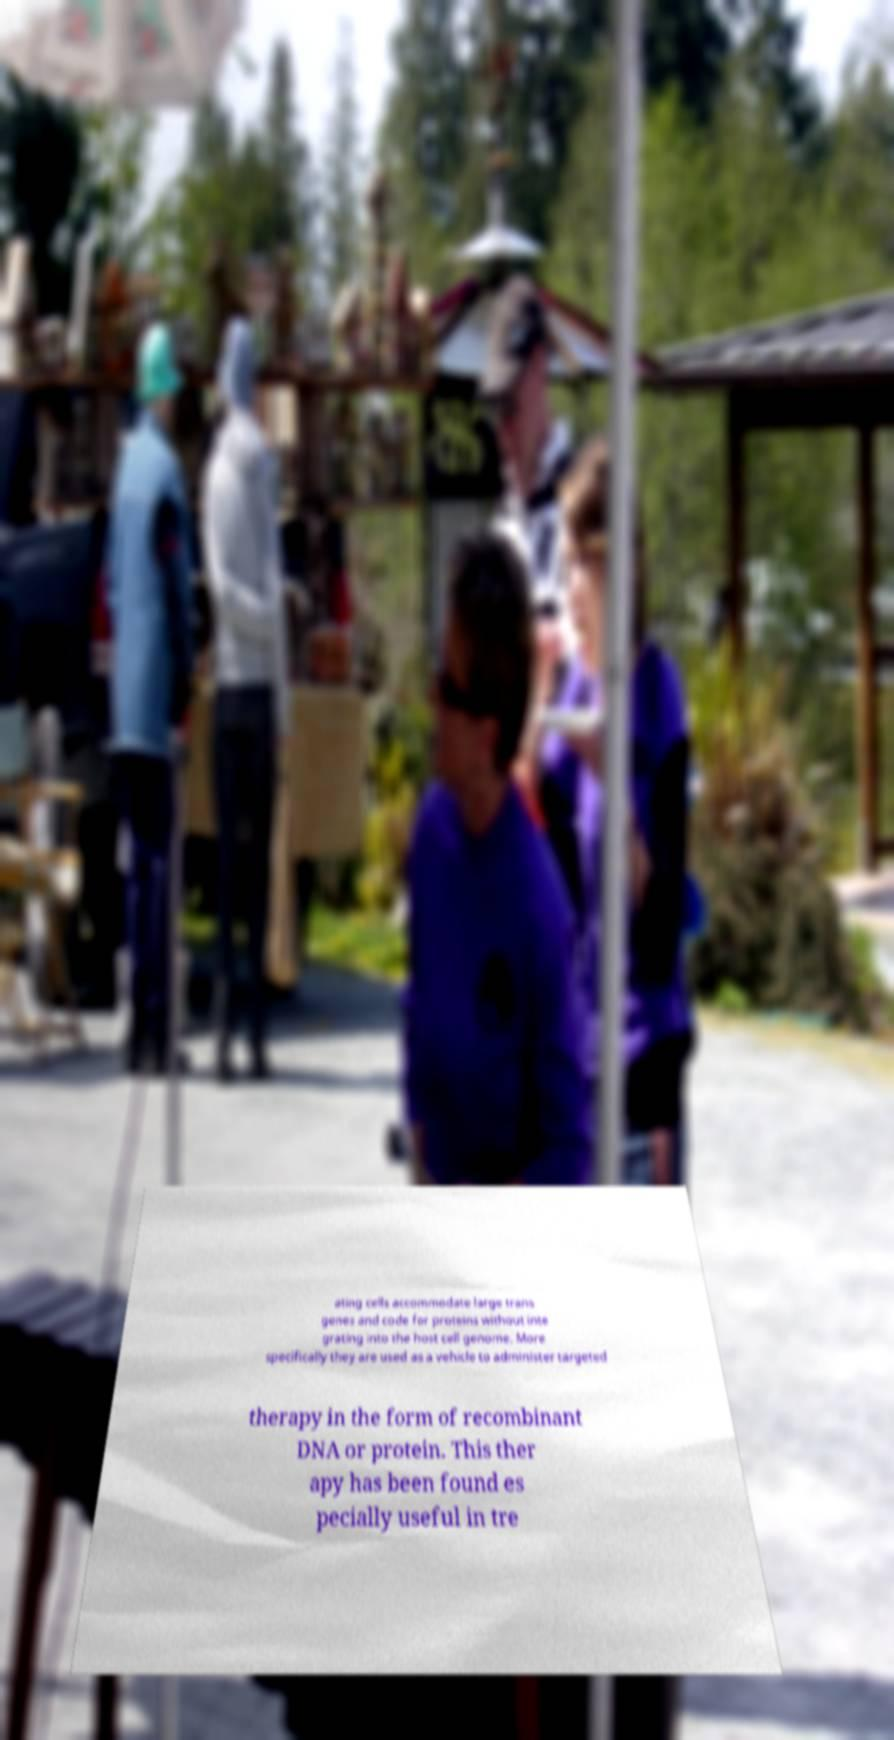There's text embedded in this image that I need extracted. Can you transcribe it verbatim? ating cells accommodate large trans genes and code for proteins without inte grating into the host cell genome. More specifically they are used as a vehicle to administer targeted therapy in the form of recombinant DNA or protein. This ther apy has been found es pecially useful in tre 